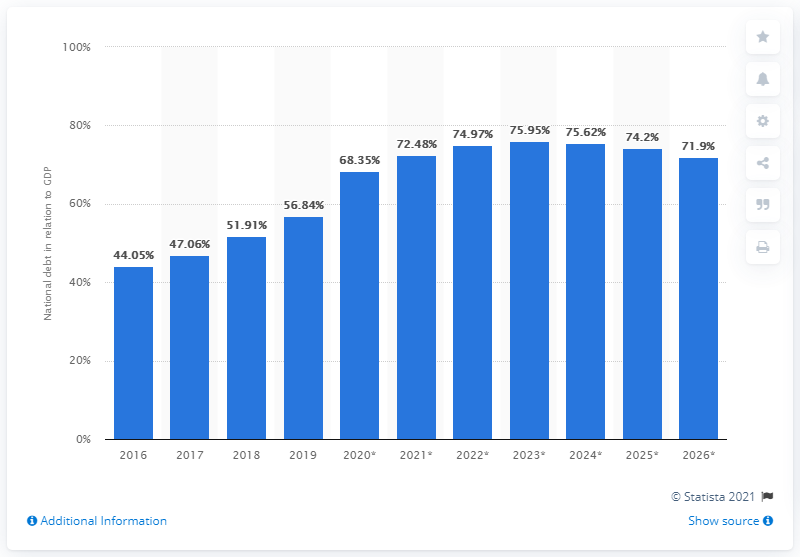Identify some key points in this picture. In 2019, the national debt of Costa Rica accounted for approximately 56.84% of the country's Gross Domestic Product (GDP). 